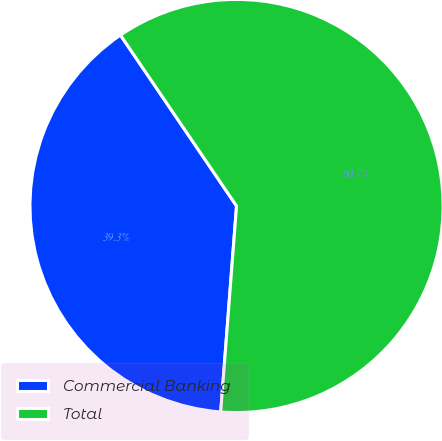Convert chart to OTSL. <chart><loc_0><loc_0><loc_500><loc_500><pie_chart><fcel>Commercial Banking<fcel>Total<nl><fcel>39.28%<fcel>60.72%<nl></chart> 